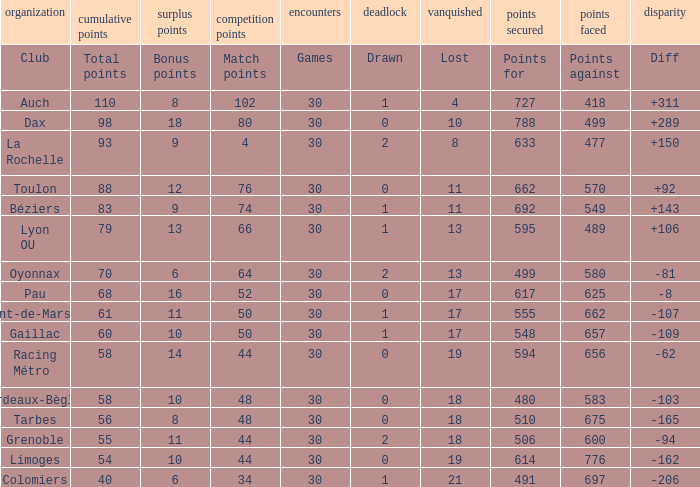What is the value of match points when the points for is 570? 76.0. 